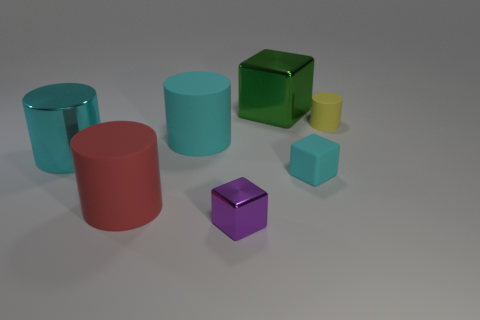The cyan thing on the right side of the shiny block that is behind the large cyan rubber thing behind the tiny cyan matte block is what shape?
Provide a succinct answer. Cube. What number of objects are tiny gray blocks or big metal objects behind the yellow thing?
Make the answer very short. 1. There is a cyan thing that is in front of the cyan metallic cylinder; what size is it?
Ensure brevity in your answer.  Small. What shape is the large rubber object that is the same color as the large metallic cylinder?
Provide a succinct answer. Cylinder. Do the tiny cylinder and the tiny cube that is on the right side of the small purple object have the same material?
Offer a very short reply. Yes. What number of cyan metallic things are on the right side of the matte object that is behind the cyan matte thing that is to the left of the small purple block?
Ensure brevity in your answer.  0. How many red objects are matte objects or small metallic balls?
Offer a terse response. 1. The metallic thing behind the tiny rubber cylinder has what shape?
Your answer should be very brief. Cube. What is the color of the metal thing that is the same size as the yellow matte cylinder?
Give a very brief answer. Purple. Do the large cyan matte thing and the large metal object in front of the large block have the same shape?
Offer a terse response. Yes. 